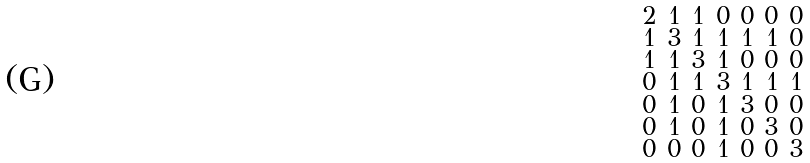Convert formula to latex. <formula><loc_0><loc_0><loc_500><loc_500>\begin{smallmatrix} 2 & 1 & 1 & 0 & 0 & 0 & 0 \\ 1 & 3 & 1 & 1 & 1 & 1 & 0 \\ 1 & 1 & 3 & 1 & 0 & 0 & 0 \\ 0 & 1 & 1 & 3 & 1 & 1 & 1 \\ 0 & 1 & 0 & 1 & 3 & 0 & 0 \\ 0 & 1 & 0 & 1 & 0 & 3 & 0 \\ 0 & 0 & 0 & 1 & 0 & 0 & 3 \end{smallmatrix}</formula> 